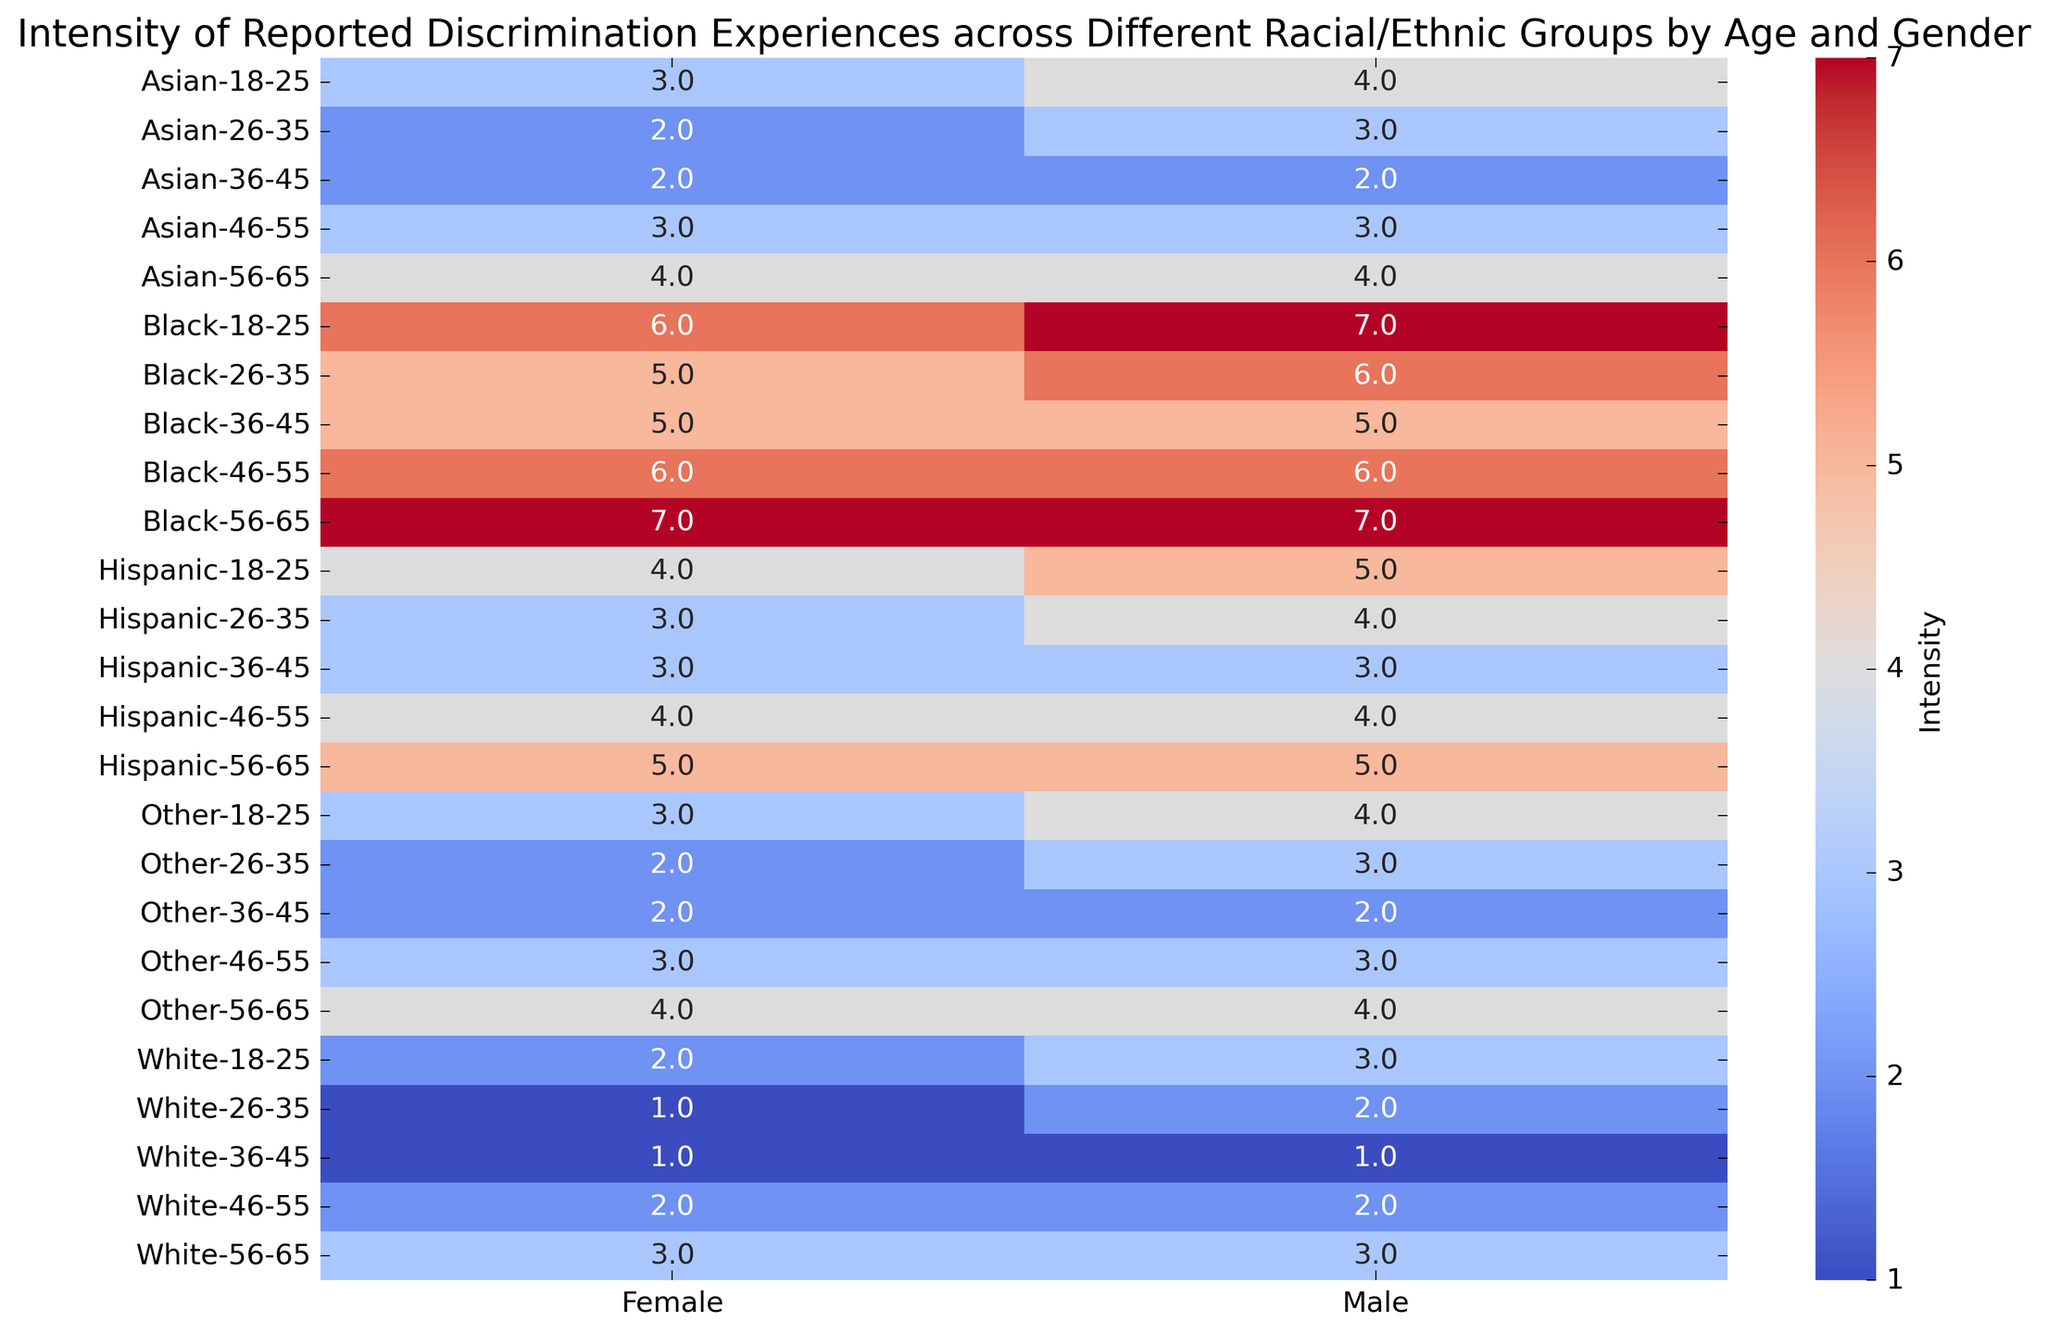Which gender reports more intense discrimination experiences in the Black racial/ethnic group for the age group 18-25? By examining the intensity values in the heatmap for the Black racial/ethnic group in the age group 18-25, we see that males have an intensity of 7 and females have an intensity of 6. Therefore, males report more intense discrimination experiences.
Answer: Males How does the intensity of reported discrimination experiences for Hispanic males aged 56-65 compare to Hispanic females of the same age group? The heatmap shows that both Hispanic males and females aged 56-65 report an intensity of 5. This means the reported discrimination experiences are the same in intensity for both genders.
Answer: Same What is the difference in perceived discrimination intensity between White males and Black males in the 26-35 age group? The heatmap shows that White males aged 26-35 have an intensity of 2, whereas Black males in the same age group have an intensity of 6. The difference is 6 - 2.
Answer: 4 In which racial/ethnic group and age category is the lowest intensity of reported discrimination found, regardless of gender? By scanning the heatmap, the lowest intensity value is 1, observed among White males and females in the 26-35 and 36-45 age groups.
Answer: White (26-45) What is the average intensity of reported discrimination experiences for Asian females across all age groups? To find the average, look at the intensity values for Asian females across all age groups (18-25: 3, 26-35: 2, 36-45: 2, 46-55: 3, 56-65: 4). Sum them (3+2+2+3+4=14), and then divide by the number of age groups (5).
Answer: 2.8 Which racial/ethnic group reports the highest overall discrimination intensity among females aged 56-65? By examining the heatmap, the highest intensity value for females aged 56-65 is 7, found in the Black racial/ethnic group.
Answer: Black Are there any age groups where male and female reports of discrimination intensity are equal among all racial/ethnic groups? By checking each age group in the heatmap, we see that in the 36-45 age group, both males and females within all racial/ethnic groups (White, Black, Hispanic, Asian, Other) have equally reported discrimination intensity values.
Answer: Yes (36-45) What is the sum of reported discrimination intensities for Asian individuals across all genders and age groups? Summing the values for both Asian males and females: (4+3+3+2+2+2+3+3+4+4) = 30.
Answer: 30 